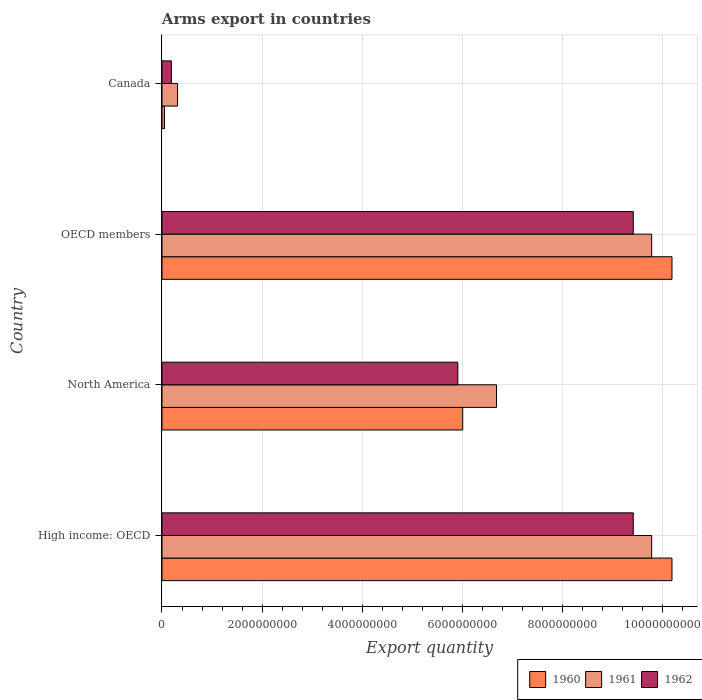How many different coloured bars are there?
Your answer should be very brief. 3. How many groups of bars are there?
Offer a very short reply. 4. Are the number of bars per tick equal to the number of legend labels?
Your response must be concise. Yes. Are the number of bars on each tick of the Y-axis equal?
Provide a succinct answer. Yes. How many bars are there on the 4th tick from the top?
Your response must be concise. 3. In how many cases, is the number of bars for a given country not equal to the number of legend labels?
Your answer should be very brief. 0. What is the total arms export in 1960 in Canada?
Ensure brevity in your answer.  5.00e+07. Across all countries, what is the maximum total arms export in 1962?
Your answer should be very brief. 9.42e+09. Across all countries, what is the minimum total arms export in 1962?
Provide a succinct answer. 1.88e+08. In which country was the total arms export in 1961 maximum?
Make the answer very short. High income: OECD. In which country was the total arms export in 1961 minimum?
Ensure brevity in your answer.  Canada. What is the total total arms export in 1960 in the graph?
Your response must be concise. 2.64e+1. What is the difference between the total arms export in 1962 in Canada and that in North America?
Offer a terse response. -5.72e+09. What is the difference between the total arms export in 1962 in High income: OECD and the total arms export in 1961 in OECD members?
Provide a short and direct response. -3.68e+08. What is the average total arms export in 1961 per country?
Offer a terse response. 6.64e+09. What is the difference between the total arms export in 1960 and total arms export in 1961 in Canada?
Offer a terse response. -2.61e+08. In how many countries, is the total arms export in 1961 greater than 7200000000 ?
Your response must be concise. 2. What is the ratio of the total arms export in 1961 in Canada to that in High income: OECD?
Your response must be concise. 0.03. What is the difference between the highest and the second highest total arms export in 1961?
Ensure brevity in your answer.  0. What is the difference between the highest and the lowest total arms export in 1962?
Keep it short and to the point. 9.23e+09. What does the 1st bar from the top in North America represents?
Offer a terse response. 1962. What does the 1st bar from the bottom in OECD members represents?
Ensure brevity in your answer.  1960. Is it the case that in every country, the sum of the total arms export in 1960 and total arms export in 1961 is greater than the total arms export in 1962?
Provide a succinct answer. Yes. How many bars are there?
Ensure brevity in your answer.  12. What is the difference between two consecutive major ticks on the X-axis?
Your answer should be compact. 2.00e+09. Are the values on the major ticks of X-axis written in scientific E-notation?
Your response must be concise. No. Does the graph contain any zero values?
Make the answer very short. No. What is the title of the graph?
Offer a terse response. Arms export in countries. What is the label or title of the X-axis?
Keep it short and to the point. Export quantity. What is the Export quantity of 1960 in High income: OECD?
Offer a terse response. 1.02e+1. What is the Export quantity of 1961 in High income: OECD?
Offer a very short reply. 9.79e+09. What is the Export quantity of 1962 in High income: OECD?
Offer a terse response. 9.42e+09. What is the Export quantity of 1960 in North America?
Offer a terse response. 6.01e+09. What is the Export quantity in 1961 in North America?
Ensure brevity in your answer.  6.69e+09. What is the Export quantity in 1962 in North America?
Your response must be concise. 5.91e+09. What is the Export quantity in 1960 in OECD members?
Your answer should be compact. 1.02e+1. What is the Export quantity in 1961 in OECD members?
Provide a short and direct response. 9.79e+09. What is the Export quantity in 1962 in OECD members?
Make the answer very short. 9.42e+09. What is the Export quantity in 1960 in Canada?
Your response must be concise. 5.00e+07. What is the Export quantity in 1961 in Canada?
Keep it short and to the point. 3.11e+08. What is the Export quantity in 1962 in Canada?
Your answer should be compact. 1.88e+08. Across all countries, what is the maximum Export quantity of 1960?
Your answer should be compact. 1.02e+1. Across all countries, what is the maximum Export quantity of 1961?
Your answer should be compact. 9.79e+09. Across all countries, what is the maximum Export quantity in 1962?
Your answer should be compact. 9.42e+09. Across all countries, what is the minimum Export quantity of 1960?
Make the answer very short. 5.00e+07. Across all countries, what is the minimum Export quantity of 1961?
Provide a short and direct response. 3.11e+08. Across all countries, what is the minimum Export quantity in 1962?
Ensure brevity in your answer.  1.88e+08. What is the total Export quantity of 1960 in the graph?
Provide a short and direct response. 2.64e+1. What is the total Export quantity in 1961 in the graph?
Provide a succinct answer. 2.66e+1. What is the total Export quantity in 1962 in the graph?
Keep it short and to the point. 2.49e+1. What is the difference between the Export quantity of 1960 in High income: OECD and that in North America?
Your answer should be very brief. 4.18e+09. What is the difference between the Export quantity of 1961 in High income: OECD and that in North America?
Provide a short and direct response. 3.10e+09. What is the difference between the Export quantity in 1962 in High income: OECD and that in North America?
Your response must be concise. 3.51e+09. What is the difference between the Export quantity of 1960 in High income: OECD and that in OECD members?
Give a very brief answer. 0. What is the difference between the Export quantity of 1961 in High income: OECD and that in OECD members?
Provide a succinct answer. 0. What is the difference between the Export quantity of 1960 in High income: OECD and that in Canada?
Provide a short and direct response. 1.01e+1. What is the difference between the Export quantity of 1961 in High income: OECD and that in Canada?
Ensure brevity in your answer.  9.48e+09. What is the difference between the Export quantity in 1962 in High income: OECD and that in Canada?
Offer a very short reply. 9.23e+09. What is the difference between the Export quantity in 1960 in North America and that in OECD members?
Keep it short and to the point. -4.18e+09. What is the difference between the Export quantity of 1961 in North America and that in OECD members?
Your response must be concise. -3.10e+09. What is the difference between the Export quantity in 1962 in North America and that in OECD members?
Your answer should be compact. -3.51e+09. What is the difference between the Export quantity of 1960 in North America and that in Canada?
Offer a terse response. 5.96e+09. What is the difference between the Export quantity in 1961 in North America and that in Canada?
Give a very brief answer. 6.38e+09. What is the difference between the Export quantity of 1962 in North America and that in Canada?
Keep it short and to the point. 5.72e+09. What is the difference between the Export quantity of 1960 in OECD members and that in Canada?
Your answer should be compact. 1.01e+1. What is the difference between the Export quantity of 1961 in OECD members and that in Canada?
Provide a short and direct response. 9.48e+09. What is the difference between the Export quantity in 1962 in OECD members and that in Canada?
Give a very brief answer. 9.23e+09. What is the difference between the Export quantity in 1960 in High income: OECD and the Export quantity in 1961 in North America?
Ensure brevity in your answer.  3.51e+09. What is the difference between the Export quantity of 1960 in High income: OECD and the Export quantity of 1962 in North America?
Your response must be concise. 4.28e+09. What is the difference between the Export quantity in 1961 in High income: OECD and the Export quantity in 1962 in North America?
Your response must be concise. 3.88e+09. What is the difference between the Export quantity of 1960 in High income: OECD and the Export quantity of 1961 in OECD members?
Your answer should be compact. 4.06e+08. What is the difference between the Export quantity of 1960 in High income: OECD and the Export quantity of 1962 in OECD members?
Make the answer very short. 7.74e+08. What is the difference between the Export quantity of 1961 in High income: OECD and the Export quantity of 1962 in OECD members?
Ensure brevity in your answer.  3.68e+08. What is the difference between the Export quantity in 1960 in High income: OECD and the Export quantity in 1961 in Canada?
Make the answer very short. 9.88e+09. What is the difference between the Export quantity in 1960 in High income: OECD and the Export quantity in 1962 in Canada?
Offer a terse response. 1.00e+1. What is the difference between the Export quantity of 1961 in High income: OECD and the Export quantity of 1962 in Canada?
Your response must be concise. 9.60e+09. What is the difference between the Export quantity in 1960 in North America and the Export quantity in 1961 in OECD members?
Your answer should be very brief. -3.78e+09. What is the difference between the Export quantity of 1960 in North America and the Export quantity of 1962 in OECD members?
Offer a very short reply. -3.41e+09. What is the difference between the Export quantity of 1961 in North America and the Export quantity of 1962 in OECD members?
Your answer should be very brief. -2.73e+09. What is the difference between the Export quantity of 1960 in North America and the Export quantity of 1961 in Canada?
Offer a very short reply. 5.70e+09. What is the difference between the Export quantity in 1960 in North America and the Export quantity in 1962 in Canada?
Keep it short and to the point. 5.82e+09. What is the difference between the Export quantity in 1961 in North America and the Export quantity in 1962 in Canada?
Offer a very short reply. 6.50e+09. What is the difference between the Export quantity in 1960 in OECD members and the Export quantity in 1961 in Canada?
Offer a terse response. 9.88e+09. What is the difference between the Export quantity in 1960 in OECD members and the Export quantity in 1962 in Canada?
Provide a succinct answer. 1.00e+1. What is the difference between the Export quantity in 1961 in OECD members and the Export quantity in 1962 in Canada?
Provide a short and direct response. 9.60e+09. What is the average Export quantity of 1960 per country?
Provide a short and direct response. 6.61e+09. What is the average Export quantity of 1961 per country?
Your answer should be very brief. 6.64e+09. What is the average Export quantity in 1962 per country?
Give a very brief answer. 6.24e+09. What is the difference between the Export quantity in 1960 and Export quantity in 1961 in High income: OECD?
Your answer should be compact. 4.06e+08. What is the difference between the Export quantity of 1960 and Export quantity of 1962 in High income: OECD?
Provide a short and direct response. 7.74e+08. What is the difference between the Export quantity of 1961 and Export quantity of 1962 in High income: OECD?
Provide a succinct answer. 3.68e+08. What is the difference between the Export quantity of 1960 and Export quantity of 1961 in North America?
Provide a short and direct response. -6.76e+08. What is the difference between the Export quantity in 1960 and Export quantity in 1962 in North America?
Your response must be concise. 9.80e+07. What is the difference between the Export quantity of 1961 and Export quantity of 1962 in North America?
Provide a short and direct response. 7.74e+08. What is the difference between the Export quantity in 1960 and Export quantity in 1961 in OECD members?
Keep it short and to the point. 4.06e+08. What is the difference between the Export quantity in 1960 and Export quantity in 1962 in OECD members?
Give a very brief answer. 7.74e+08. What is the difference between the Export quantity of 1961 and Export quantity of 1962 in OECD members?
Provide a succinct answer. 3.68e+08. What is the difference between the Export quantity of 1960 and Export quantity of 1961 in Canada?
Offer a very short reply. -2.61e+08. What is the difference between the Export quantity of 1960 and Export quantity of 1962 in Canada?
Ensure brevity in your answer.  -1.38e+08. What is the difference between the Export quantity of 1961 and Export quantity of 1962 in Canada?
Keep it short and to the point. 1.23e+08. What is the ratio of the Export quantity in 1960 in High income: OECD to that in North America?
Ensure brevity in your answer.  1.7. What is the ratio of the Export quantity in 1961 in High income: OECD to that in North America?
Your answer should be compact. 1.46. What is the ratio of the Export quantity of 1962 in High income: OECD to that in North America?
Provide a short and direct response. 1.59. What is the ratio of the Export quantity in 1960 in High income: OECD to that in OECD members?
Keep it short and to the point. 1. What is the ratio of the Export quantity in 1961 in High income: OECD to that in OECD members?
Your response must be concise. 1. What is the ratio of the Export quantity in 1960 in High income: OECD to that in Canada?
Your answer should be compact. 203.88. What is the ratio of the Export quantity of 1961 in High income: OECD to that in Canada?
Provide a succinct answer. 31.47. What is the ratio of the Export quantity of 1962 in High income: OECD to that in Canada?
Ensure brevity in your answer.  50.11. What is the ratio of the Export quantity in 1960 in North America to that in OECD members?
Provide a succinct answer. 0.59. What is the ratio of the Export quantity of 1961 in North America to that in OECD members?
Give a very brief answer. 0.68. What is the ratio of the Export quantity of 1962 in North America to that in OECD members?
Give a very brief answer. 0.63. What is the ratio of the Export quantity in 1960 in North America to that in Canada?
Give a very brief answer. 120.22. What is the ratio of the Export quantity of 1961 in North America to that in Canada?
Keep it short and to the point. 21.5. What is the ratio of the Export quantity of 1962 in North America to that in Canada?
Offer a terse response. 31.45. What is the ratio of the Export quantity in 1960 in OECD members to that in Canada?
Your answer should be compact. 203.88. What is the ratio of the Export quantity of 1961 in OECD members to that in Canada?
Offer a terse response. 31.47. What is the ratio of the Export quantity in 1962 in OECD members to that in Canada?
Your response must be concise. 50.11. What is the difference between the highest and the lowest Export quantity of 1960?
Offer a terse response. 1.01e+1. What is the difference between the highest and the lowest Export quantity of 1961?
Your response must be concise. 9.48e+09. What is the difference between the highest and the lowest Export quantity in 1962?
Make the answer very short. 9.23e+09. 